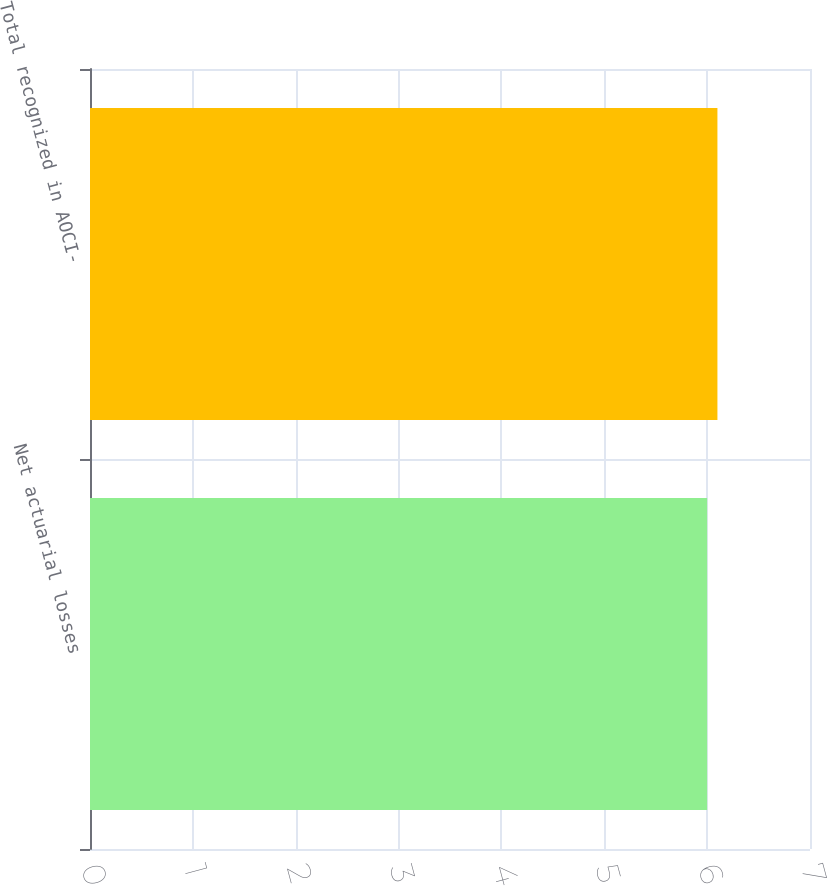Convert chart. <chart><loc_0><loc_0><loc_500><loc_500><bar_chart><fcel>Net actuarial losses<fcel>Total recognized in AOCI-<nl><fcel>6<fcel>6.1<nl></chart> 